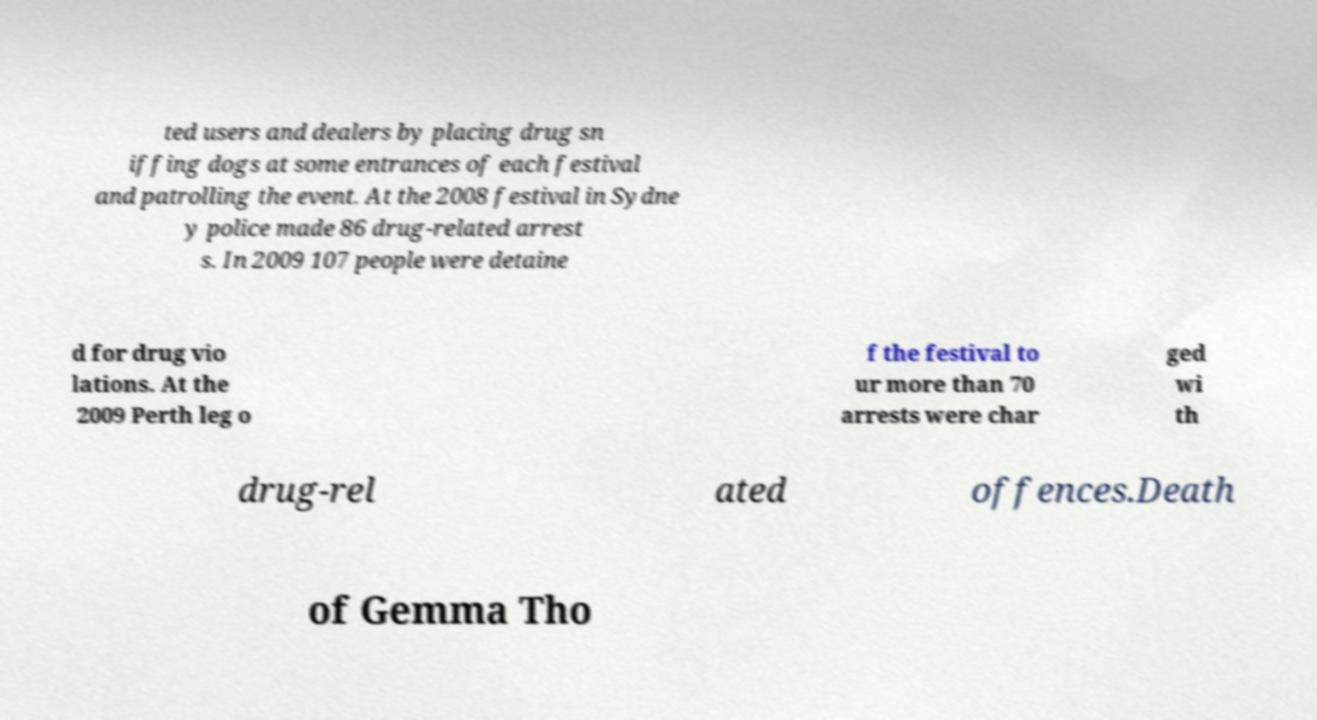What messages or text are displayed in this image? I need them in a readable, typed format. ted users and dealers by placing drug sn iffing dogs at some entrances of each festival and patrolling the event. At the 2008 festival in Sydne y police made 86 drug-related arrest s. In 2009 107 people were detaine d for drug vio lations. At the 2009 Perth leg o f the festival to ur more than 70 arrests were char ged wi th drug-rel ated offences.Death of Gemma Tho 